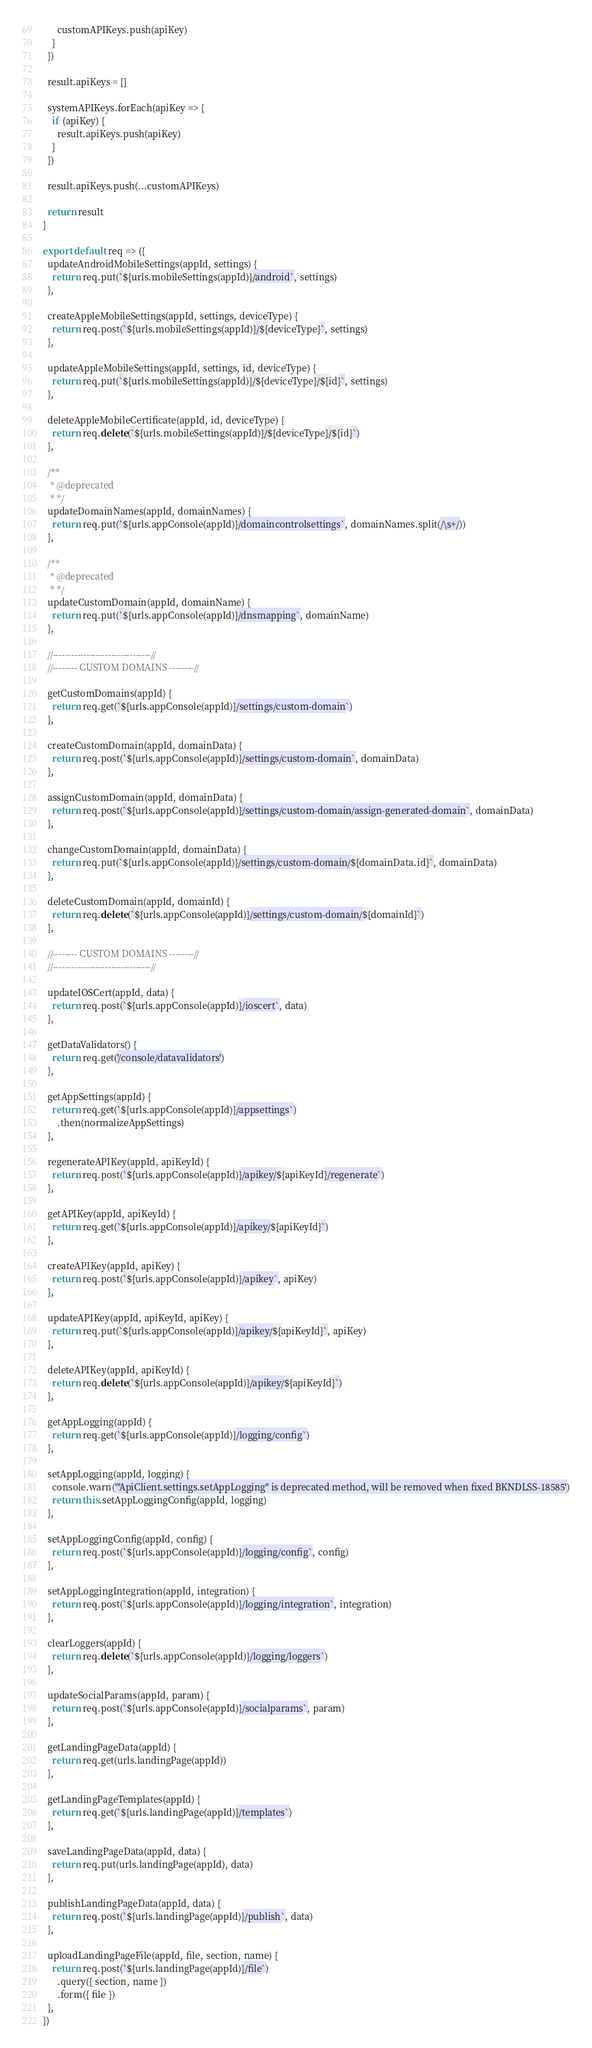Convert code to text. <code><loc_0><loc_0><loc_500><loc_500><_JavaScript_>      customAPIKeys.push(apiKey)
    }
  })

  result.apiKeys = []

  systemAPIKeys.forEach(apiKey => {
    if (apiKey) {
      result.apiKeys.push(apiKey)
    }
  })

  result.apiKeys.push(...customAPIKeys)

  return result
}

export default req => ({
  updateAndroidMobileSettings(appId, settings) {
    return req.put(`${urls.mobileSettings(appId)}/android`, settings)
  },

  createAppleMobileSettings(appId, settings, deviceType) {
    return req.post(`${urls.mobileSettings(appId)}/${deviceType}`, settings)
  },

  updateAppleMobileSettings(appId, settings, id, deviceType) {
    return req.put(`${urls.mobileSettings(appId)}/${deviceType}/${id}`, settings)
  },

  deleteAppleMobileCertificate(appId, id, deviceType) {
    return req.delete(`${urls.mobileSettings(appId)}/${deviceType}/${id}`)
  },

  /**
   * @deprecated
   * */
  updateDomainNames(appId, domainNames) {
    return req.put(`${urls.appConsole(appId)}/domaincontrolsettings`, domainNames.split(/\s+/))
  },

  /**
   * @deprecated
   * */
  updateCustomDomain(appId, domainName) {
    return req.put(`${urls.appConsole(appId)}/dnsmapping`, domainName)
  },

  //--------------------------------//
  //-------- CUSTOM DOMAINS --------//

  getCustomDomains(appId) {
    return req.get(`${urls.appConsole(appId)}/settings/custom-domain`)
  },

  createCustomDomain(appId, domainData) {
    return req.post(`${urls.appConsole(appId)}/settings/custom-domain`, domainData)
  },

  assignCustomDomain(appId, domainData) {
    return req.post(`${urls.appConsole(appId)}/settings/custom-domain/assign-generated-domain`, domainData)
  },

  changeCustomDomain(appId, domainData) {
    return req.put(`${urls.appConsole(appId)}/settings/custom-domain/${domainData.id}`, domainData)
  },

  deleteCustomDomain(appId, domainId) {
    return req.delete(`${urls.appConsole(appId)}/settings/custom-domain/${domainId}`)
  },

  //-------- CUSTOM DOMAINS --------//
  //--------------------------------//

  updateIOSCert(appId, data) {
    return req.post(`${urls.appConsole(appId)}/ioscert`, data)
  },

  getDataValidators() {
    return req.get('/console/datavalidators')
  },

  getAppSettings(appId) {
    return req.get(`${urls.appConsole(appId)}/appsettings`)
      .then(normalizeAppSettings)
  },

  regenerateAPIKey(appId, apiKeyId) {
    return req.post(`${urls.appConsole(appId)}/apikey/${apiKeyId}/regenerate`)
  },

  getAPIKey(appId, apiKeyId) {
    return req.get(`${urls.appConsole(appId)}/apikey/${apiKeyId}`)
  },

  createAPIKey(appId, apiKey) {
    return req.post(`${urls.appConsole(appId)}/apikey`, apiKey)
  },

  updateAPIKey(appId, apiKeyId, apiKey) {
    return req.put(`${urls.appConsole(appId)}/apikey/${apiKeyId}`, apiKey)
  },

  deleteAPIKey(appId, apiKeyId) {
    return req.delete(`${urls.appConsole(appId)}/apikey/${apiKeyId}`)
  },

  getAppLogging(appId) {
    return req.get(`${urls.appConsole(appId)}/logging/config`)
  },

  setAppLogging(appId, logging) {
    console.warn('"ApiClient.settings.setAppLogging" is deprecated method, will be removed when fixed BKNDLSS-18585')
    return this.setAppLoggingConfig(appId, logging)
  },

  setAppLoggingConfig(appId, config) {
    return req.post(`${urls.appConsole(appId)}/logging/config`, config)
  },

  setAppLoggingIntegration(appId, integration) {
    return req.post(`${urls.appConsole(appId)}/logging/integration`, integration)
  },

  clearLoggers(appId) {
    return req.delete(`${urls.appConsole(appId)}/logging/loggers`)
  },

  updateSocialParams(appId, param) {
    return req.post(`${urls.appConsole(appId)}/socialparams`, param)
  },

  getLandingPageData(appId) {
    return req.get(urls.landingPage(appId))
  },

  getLandingPageTemplates(appId) {
    return req.get(`${urls.landingPage(appId)}/templates`)
  },

  saveLandingPageData(appId, data) {
    return req.put(urls.landingPage(appId), data)
  },

  publishLandingPageData(appId, data) {
    return req.post(`${urls.landingPage(appId)}/publish`, data)
  },

  uploadLandingPageFile(appId, file, section, name) {
    return req.post(`${urls.landingPage(appId)}/file`)
      .query({ section, name })
      .form({ file })
  },
})
</code> 